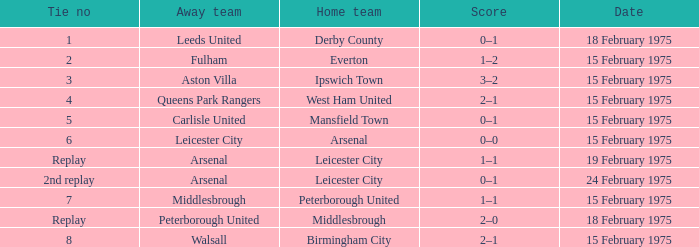On which date was the away team carlisle united? 15 February 1975. 